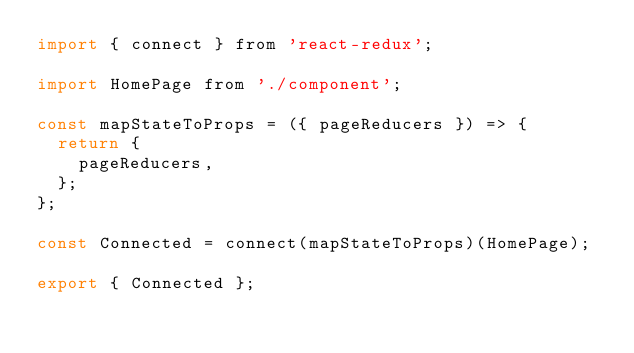Convert code to text. <code><loc_0><loc_0><loc_500><loc_500><_JavaScript_>import { connect } from 'react-redux';

import HomePage from './component';

const mapStateToProps = ({ pageReducers }) => {
  return {
    pageReducers,
  };
};

const Connected = connect(mapStateToProps)(HomePage);

export { Connected };
</code> 